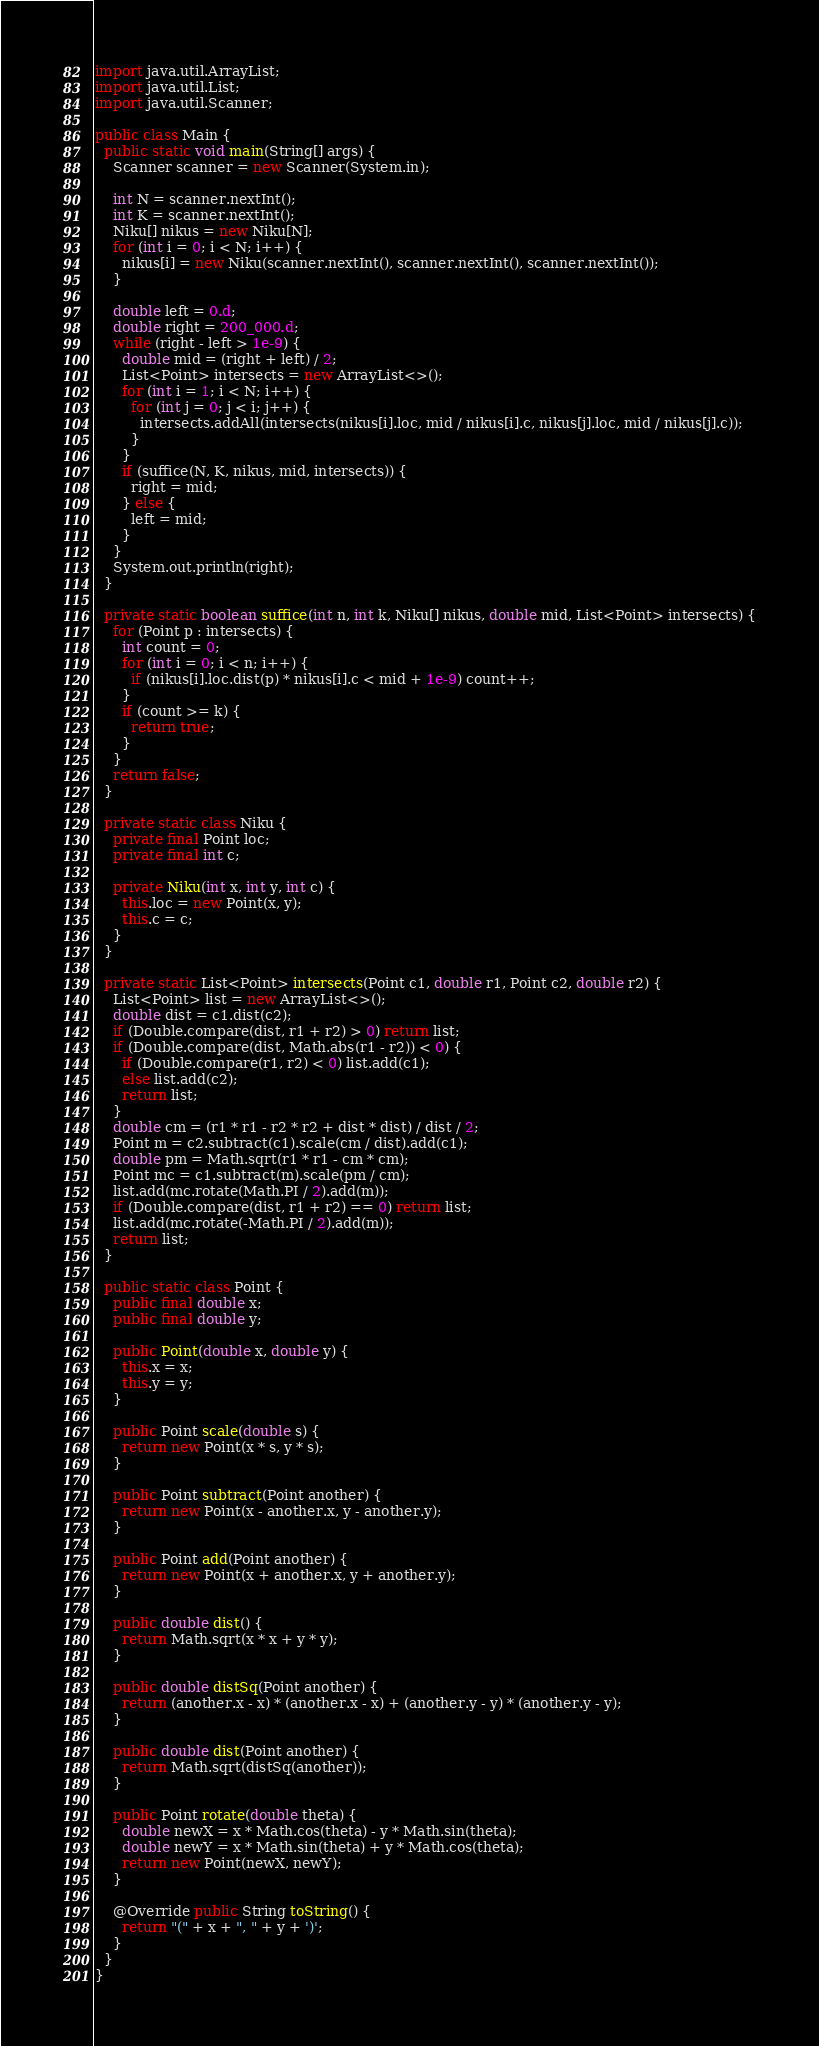Convert code to text. <code><loc_0><loc_0><loc_500><loc_500><_Java_>import java.util.ArrayList;
import java.util.List;
import java.util.Scanner;

public class Main {
  public static void main(String[] args) {
    Scanner scanner = new Scanner(System.in);

    int N = scanner.nextInt();
    int K = scanner.nextInt();
    Niku[] nikus = new Niku[N];
    for (int i = 0; i < N; i++) {
      nikus[i] = new Niku(scanner.nextInt(), scanner.nextInt(), scanner.nextInt());
    }

    double left = 0.d;
    double right = 200_000.d;
    while (right - left > 1e-9) {
      double mid = (right + left) / 2;
      List<Point> intersects = new ArrayList<>();
      for (int i = 1; i < N; i++) {
        for (int j = 0; j < i; j++) {
          intersects.addAll(intersects(nikus[i].loc, mid / nikus[i].c, nikus[j].loc, mid / nikus[j].c));
        }
      }
      if (suffice(N, K, nikus, mid, intersects)) {
        right = mid;
      } else {
        left = mid;
      }
    }
    System.out.println(right);
  }

  private static boolean suffice(int n, int k, Niku[] nikus, double mid, List<Point> intersects) {
    for (Point p : intersects) {
      int count = 0;
      for (int i = 0; i < n; i++) {
        if (nikus[i].loc.dist(p) * nikus[i].c < mid + 1e-9) count++;
      }
      if (count >= k) {
        return true;
      }
    }
    return false;
  }

  private static class Niku {
    private final Point loc;
    private final int c;

    private Niku(int x, int y, int c) {
      this.loc = new Point(x, y);
      this.c = c;
    }
  }

  private static List<Point> intersects(Point c1, double r1, Point c2, double r2) {
    List<Point> list = new ArrayList<>();
    double dist = c1.dist(c2);
    if (Double.compare(dist, r1 + r2) > 0) return list;
    if (Double.compare(dist, Math.abs(r1 - r2)) < 0) {
      if (Double.compare(r1, r2) < 0) list.add(c1);
      else list.add(c2);
      return list;
    }
    double cm = (r1 * r1 - r2 * r2 + dist * dist) / dist / 2;
    Point m = c2.subtract(c1).scale(cm / dist).add(c1);
    double pm = Math.sqrt(r1 * r1 - cm * cm);
    Point mc = c1.subtract(m).scale(pm / cm);
    list.add(mc.rotate(Math.PI / 2).add(m));
    if (Double.compare(dist, r1 + r2) == 0) return list;
    list.add(mc.rotate(-Math.PI / 2).add(m));
    return list;
  }

  public static class Point {
    public final double x;
    public final double y;

    public Point(double x, double y) {
      this.x = x;
      this.y = y;
    }

    public Point scale(double s) {
      return new Point(x * s, y * s);
    }

    public Point subtract(Point another) {
      return new Point(x - another.x, y - another.y);
    }

    public Point add(Point another) {
      return new Point(x + another.x, y + another.y);
    }

    public double dist() {
      return Math.sqrt(x * x + y * y);
    }

    public double distSq(Point another) {
      return (another.x - x) * (another.x - x) + (another.y - y) * (another.y - y);
    }

    public double dist(Point another) {
      return Math.sqrt(distSq(another));
    }

    public Point rotate(double theta) {
      double newX = x * Math.cos(theta) - y * Math.sin(theta);
      double newY = x * Math.sin(theta) + y * Math.cos(theta);
      return new Point(newX, newY);
    }

    @Override public String toString() {
      return "(" + x + ", " + y + ')';
    }
  }
}
</code> 